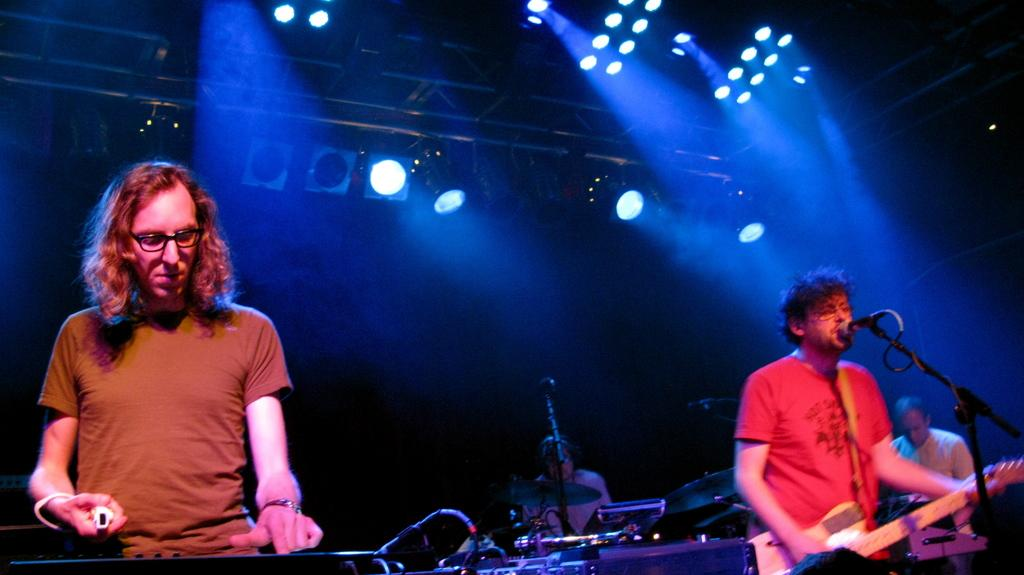How many persons are in the image? There are persons in the image. What are the persons wearing? The persons are wearing clothes. What are the persons doing in the image? The persons are playing musical instruments. What can be seen in the bottom right of the image? There is a mic in the bottom right of the image. What is visible at the top of the image? There are lights at the top of the image. What type of memory is being used by the persons in the image? There is no indication in the image that the persons are using any specific type of memory. Can you tell me how many bites the vase has taken in the image? There is no vase present in the image, so it cannot be determined how many bites it has taken. 